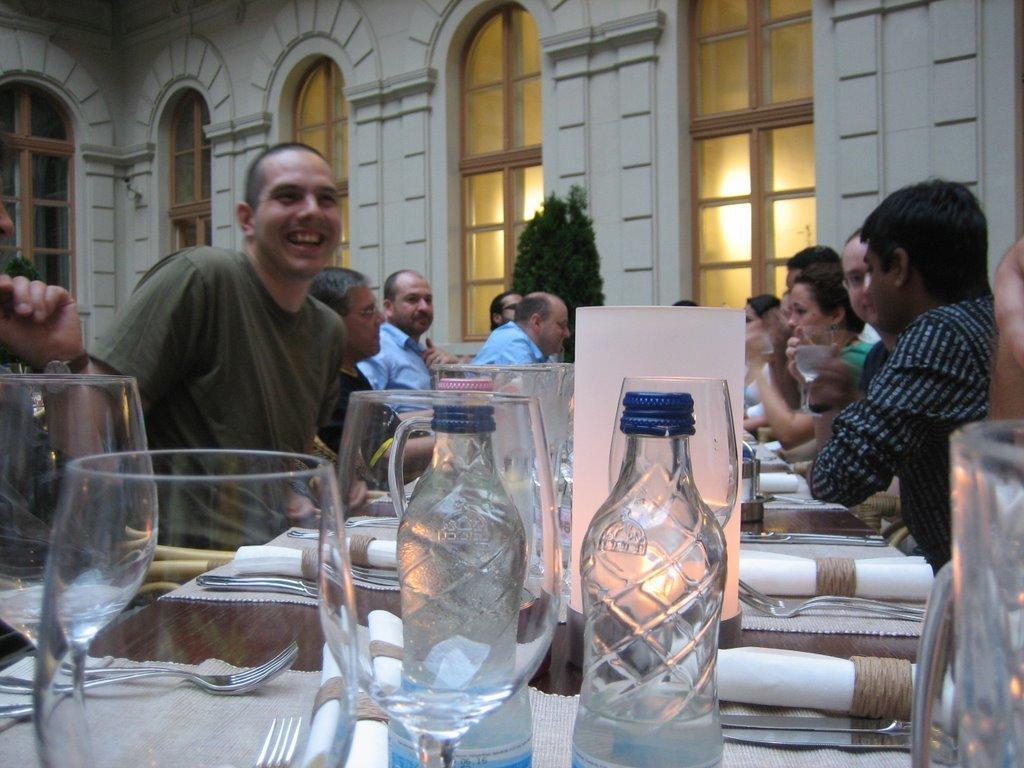Describe this image in one or two sentences. In the image we can see that, there are many people sitting around the table. On the table there are bottles, wine glasses, fork and a paper. This is s building and a plant. 